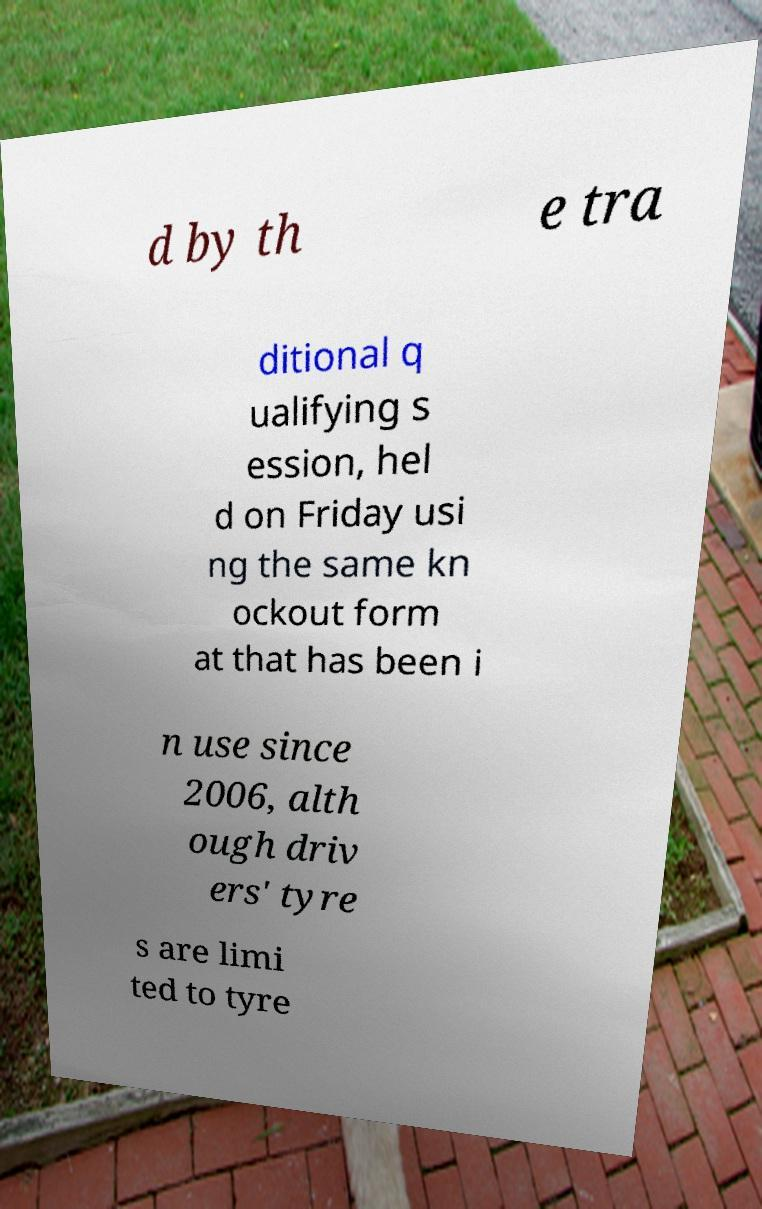Please identify and transcribe the text found in this image. d by th e tra ditional q ualifying s ession, hel d on Friday usi ng the same kn ockout form at that has been i n use since 2006, alth ough driv ers' tyre s are limi ted to tyre 